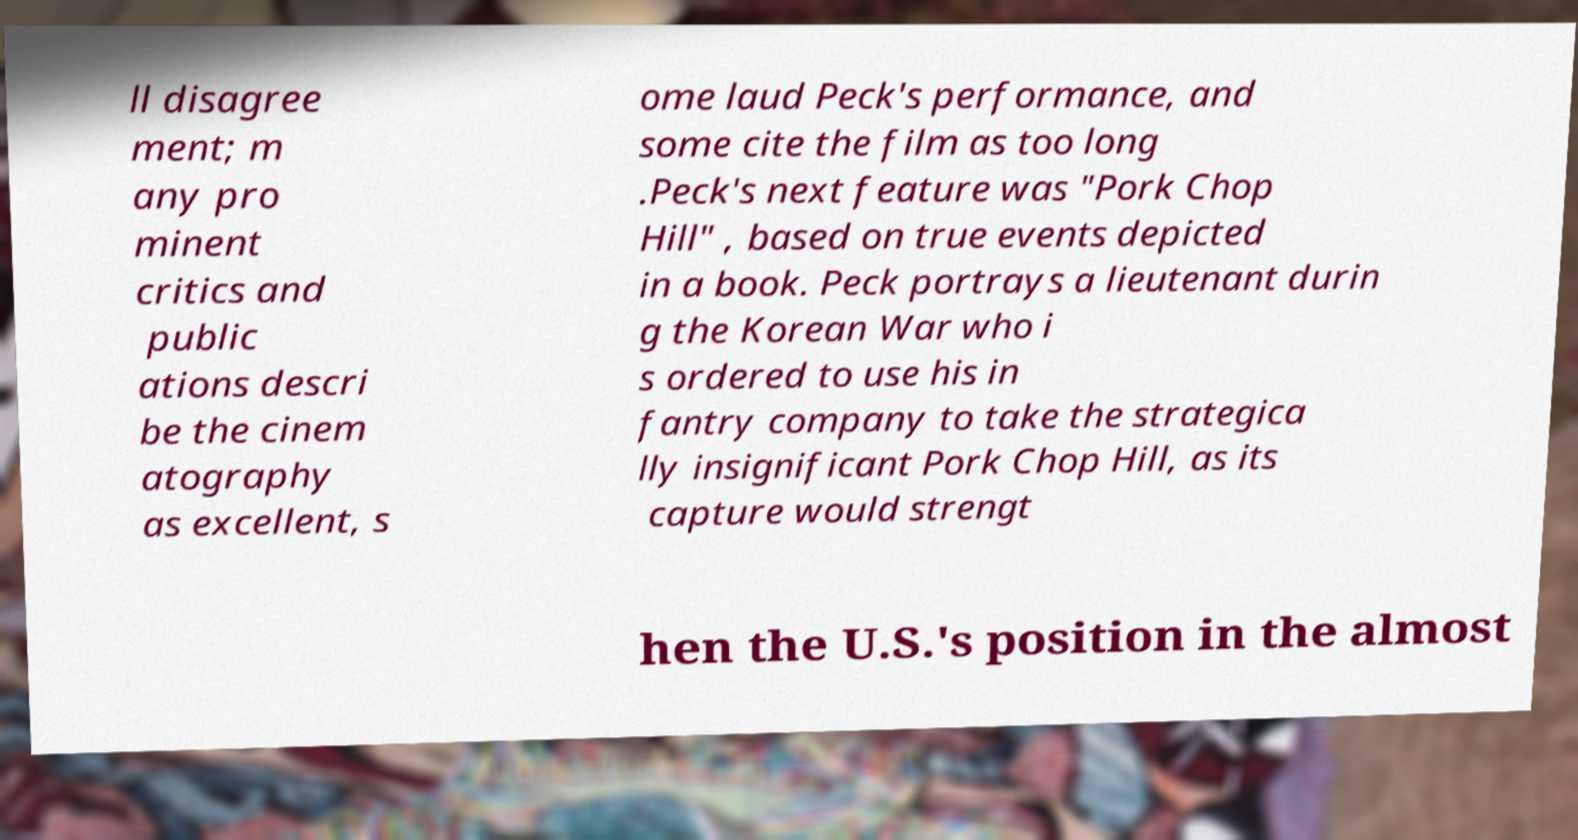Please identify and transcribe the text found in this image. ll disagree ment; m any pro minent critics and public ations descri be the cinem atography as excellent, s ome laud Peck's performance, and some cite the film as too long .Peck's next feature was "Pork Chop Hill" , based on true events depicted in a book. Peck portrays a lieutenant durin g the Korean War who i s ordered to use his in fantry company to take the strategica lly insignificant Pork Chop Hill, as its capture would strengt hen the U.S.'s position in the almost 